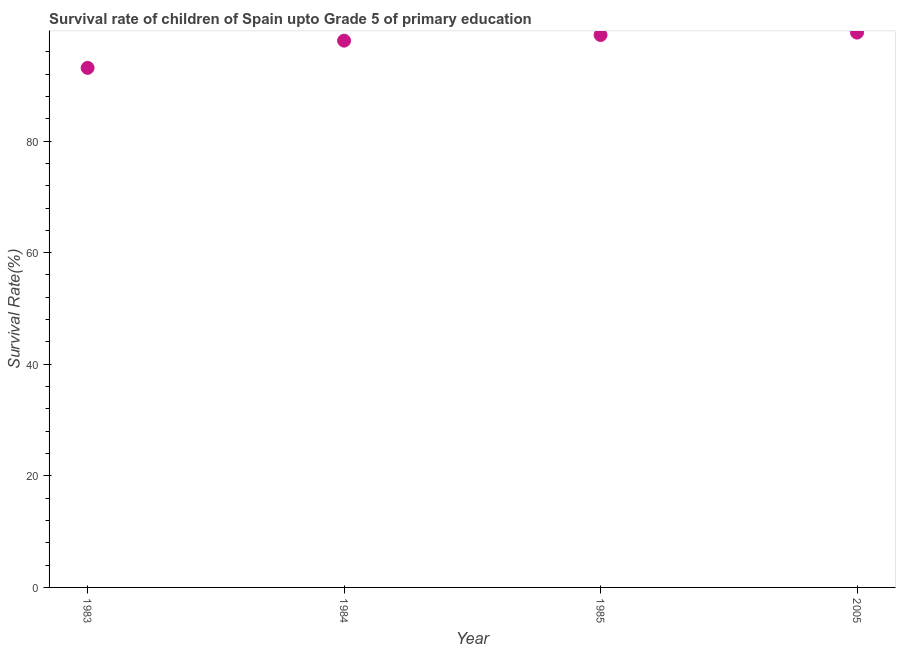What is the survival rate in 1984?
Make the answer very short. 98. Across all years, what is the maximum survival rate?
Your answer should be very brief. 99.45. Across all years, what is the minimum survival rate?
Provide a short and direct response. 93.12. In which year was the survival rate maximum?
Offer a very short reply. 2005. In which year was the survival rate minimum?
Your answer should be compact. 1983. What is the sum of the survival rate?
Your response must be concise. 389.59. What is the difference between the survival rate in 1984 and 2005?
Provide a succinct answer. -1.45. What is the average survival rate per year?
Provide a short and direct response. 97.4. What is the median survival rate?
Your answer should be very brief. 98.51. In how many years, is the survival rate greater than 40 %?
Make the answer very short. 4. Do a majority of the years between 1984 and 2005 (inclusive) have survival rate greater than 36 %?
Your answer should be compact. Yes. What is the ratio of the survival rate in 1984 to that in 1985?
Your response must be concise. 0.99. What is the difference between the highest and the second highest survival rate?
Offer a very short reply. 0.43. What is the difference between the highest and the lowest survival rate?
Give a very brief answer. 6.32. In how many years, is the survival rate greater than the average survival rate taken over all years?
Make the answer very short. 3. Does the survival rate monotonically increase over the years?
Your answer should be compact. Yes. Are the values on the major ticks of Y-axis written in scientific E-notation?
Keep it short and to the point. No. What is the title of the graph?
Provide a short and direct response. Survival rate of children of Spain upto Grade 5 of primary education. What is the label or title of the Y-axis?
Provide a succinct answer. Survival Rate(%). What is the Survival Rate(%) in 1983?
Your answer should be very brief. 93.12. What is the Survival Rate(%) in 1984?
Your answer should be very brief. 98. What is the Survival Rate(%) in 1985?
Provide a succinct answer. 99.02. What is the Survival Rate(%) in 2005?
Provide a succinct answer. 99.45. What is the difference between the Survival Rate(%) in 1983 and 1984?
Your answer should be compact. -4.88. What is the difference between the Survival Rate(%) in 1983 and 1985?
Make the answer very short. -5.89. What is the difference between the Survival Rate(%) in 1983 and 2005?
Your answer should be compact. -6.32. What is the difference between the Survival Rate(%) in 1984 and 1985?
Provide a short and direct response. -1.02. What is the difference between the Survival Rate(%) in 1984 and 2005?
Ensure brevity in your answer.  -1.45. What is the difference between the Survival Rate(%) in 1985 and 2005?
Your answer should be very brief. -0.43. What is the ratio of the Survival Rate(%) in 1983 to that in 1984?
Your response must be concise. 0.95. What is the ratio of the Survival Rate(%) in 1983 to that in 2005?
Your answer should be very brief. 0.94. What is the ratio of the Survival Rate(%) in 1985 to that in 2005?
Make the answer very short. 1. 